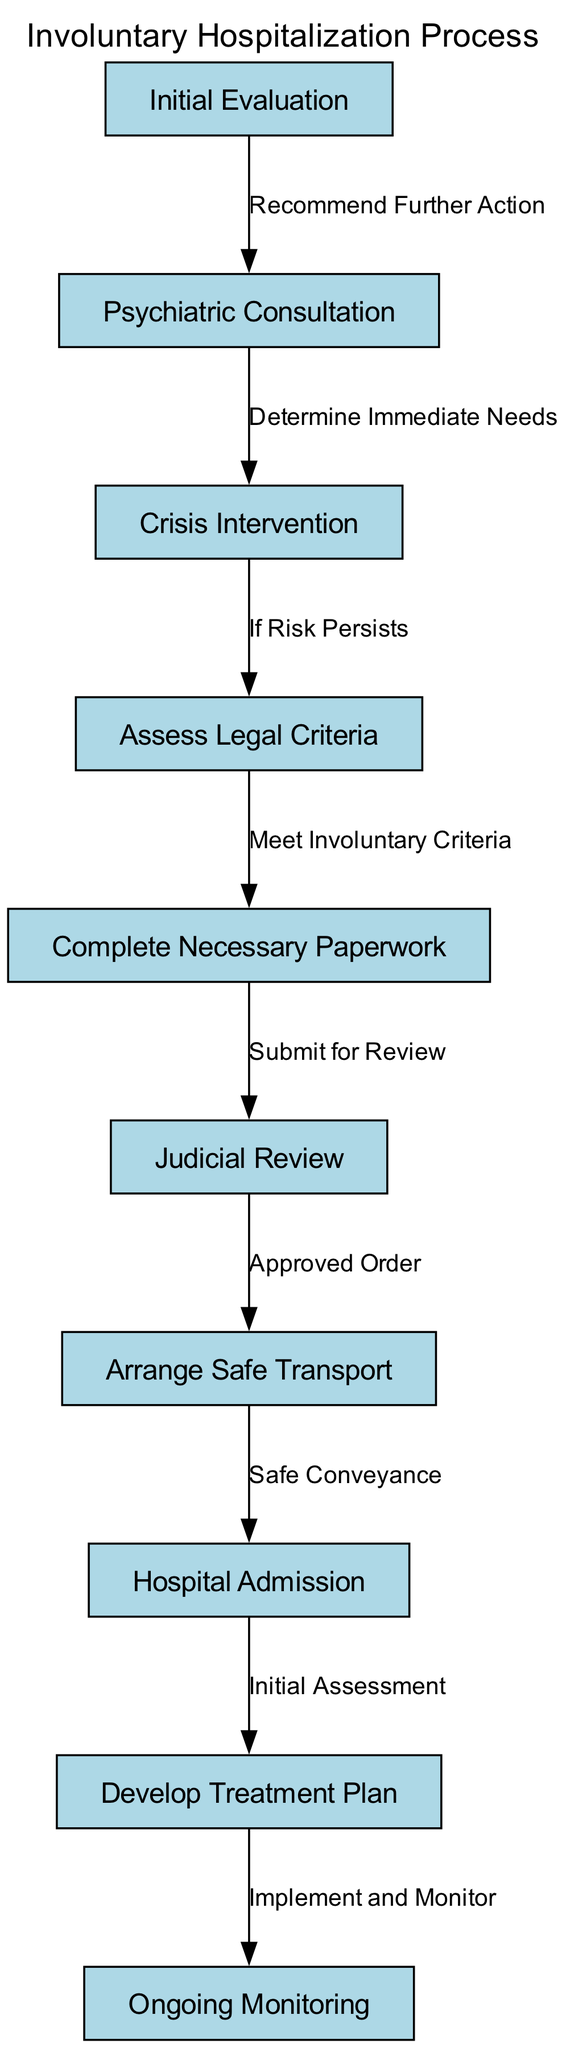What is the first step in the hospitalization process? The diagram starts with "Initial Evaluation," which is the first node and action in the involuntary hospitalization process.
Answer: Initial Evaluation How many nodes are in the diagram? The diagram contains a total of ten nodes, as evidenced by the enumeration of distinct steps in the involuntary hospitalization process.
Answer: 10 What action follows after completing the necessary paperwork? The flow indicates that the next step after "Complete Necessary Paperwork" is "Judicial Review," connected by an edge labeled "Submit for Review."
Answer: Judicial Review What is the final step of the process? The last node in the diagram is "Ongoing Monitoring," which comes after implementing the treatment plan, making it the final step of the process.
Answer: Ongoing Monitoring Which step requires determining immediate needs? The step that requires determining immediate needs is "Psychiatric Consultation," as indicated by the directed edge from "Psychiatric Consultation" to "Crisis Intervention" labeled "Determine Immediate Needs."
Answer: Psychiatric Consultation Before hospital admission, what is the action taken after the judicial review? Following the "Judicial Review," the action taken before the hospital admission is to "Arrange Safe Transport" as shown by the edge labeled "Approved Order."
Answer: Arrange Safe Transport What step occurs if risk persists after crisis intervention? If risk persists following "Crisis Intervention," the next step in the diagram is to "Assess Legal Criteria," indicating the need for evaluating legal criteria for involuntary admission.
Answer: Assess Legal Criteria What label describes the connection between "Legal Criteria" and "Paperwork"? The connection from "Legal Criteria" to "Complete Necessary Paperwork" is labeled "Meet Involuntary Criteria," indicating a necessary step in the process.
Answer: Meet Involuntary Criteria How many edges are present in the diagram? The diagram exhibits nine edges that describe the relationships and progression between the various steps of the involuntary hospitalization process, as depicted in the edges section.
Answer: 9 